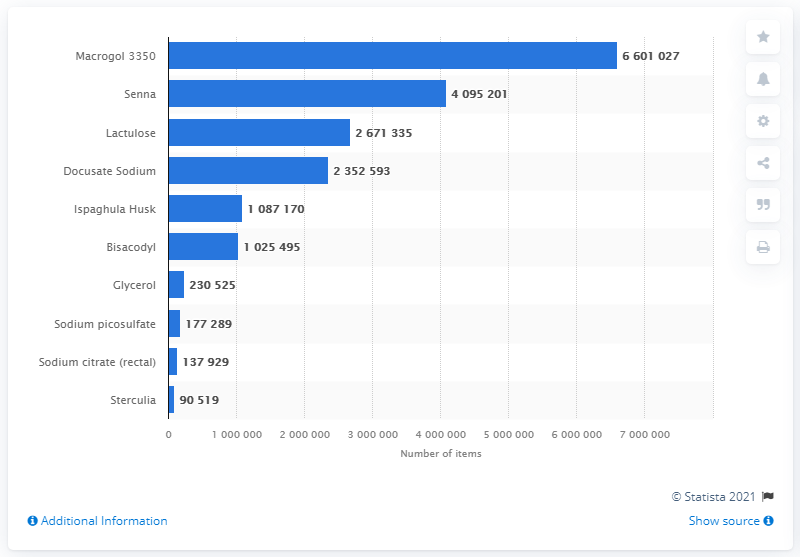Identify some key points in this picture. In 2020, the most commonly prescribed laxative in England was Macrogol 3350. The total number of items of Macrogol 3350 dispensed in 2020 was 6601027. 